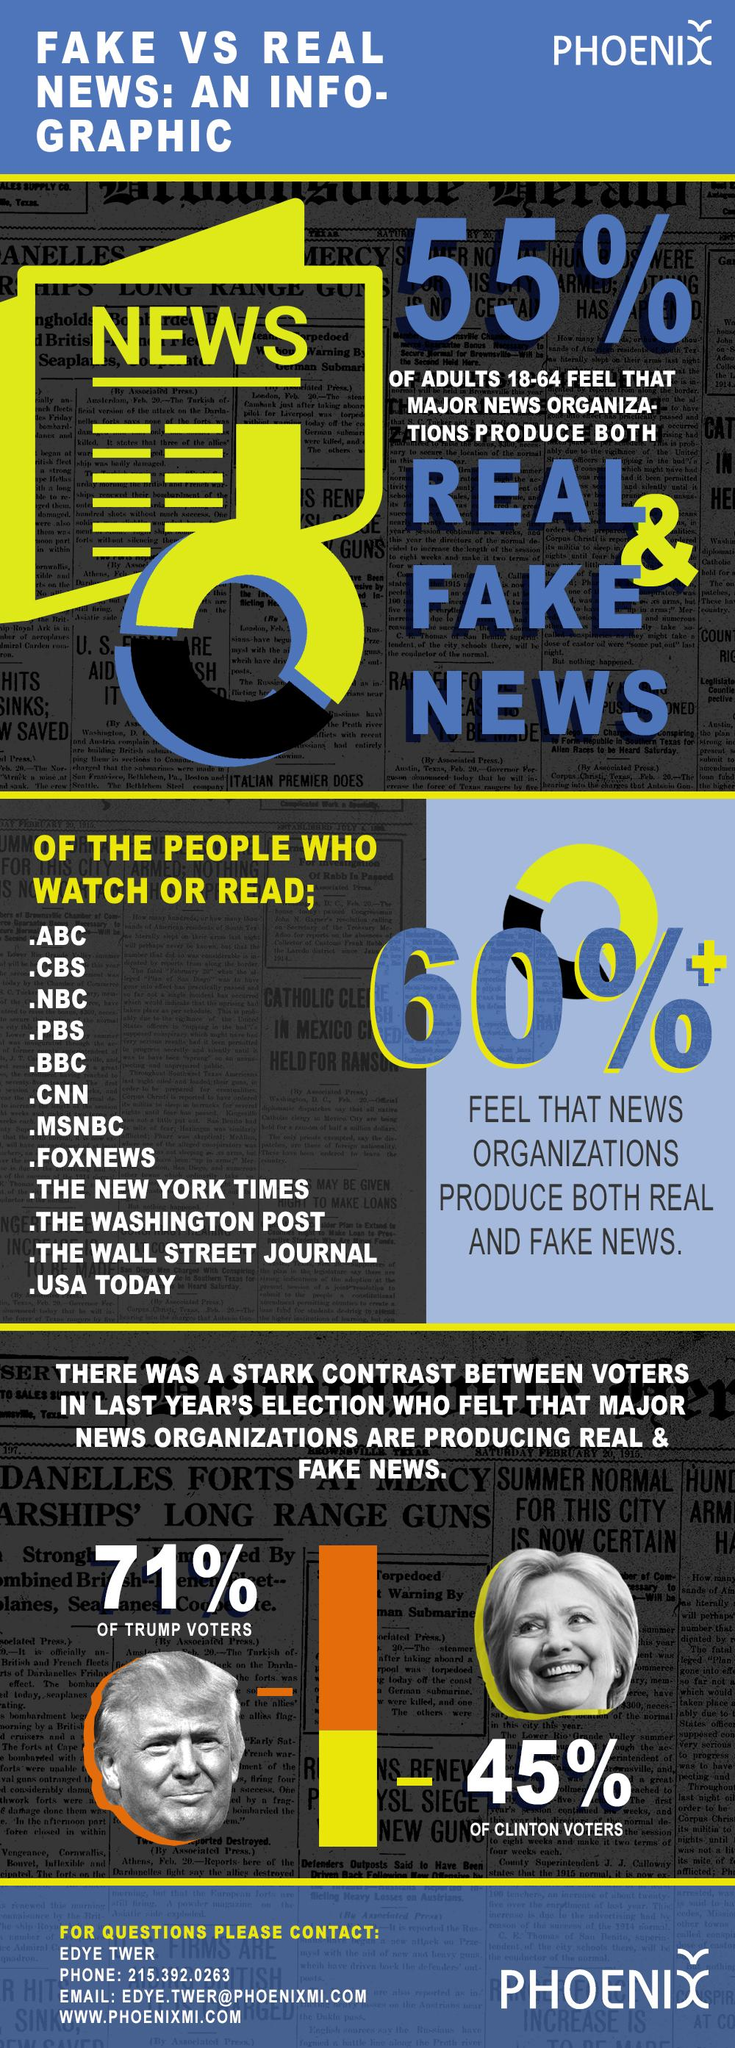Point out several critical features in this image. The first three news organizations mentioned are ABC, CBS, and NBC. A survey of Clinton voters found that 45% believed that news organizations were producing both real and fake news. According to a recent survey, 55% of adults believe that major news organizations produce both real and fake news. A recent survey found that 71% of Trump voters believed that news organizations were producing both real and fake news. 